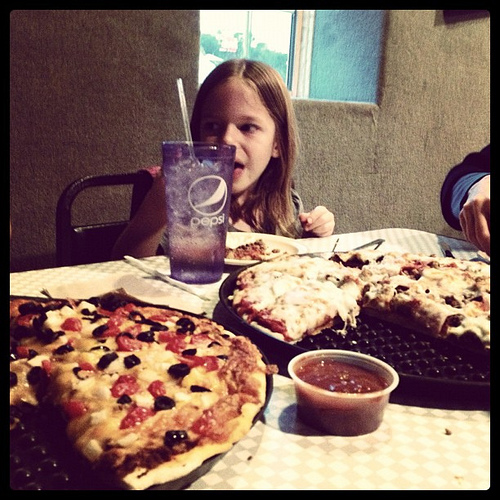How many cups of tomato sauce is there? It's difficult to determine the exact quantity of tomato sauce from the image alone, but typically, each pizza might have around one to one and a half cups of tomato sauce spread over the crust. 